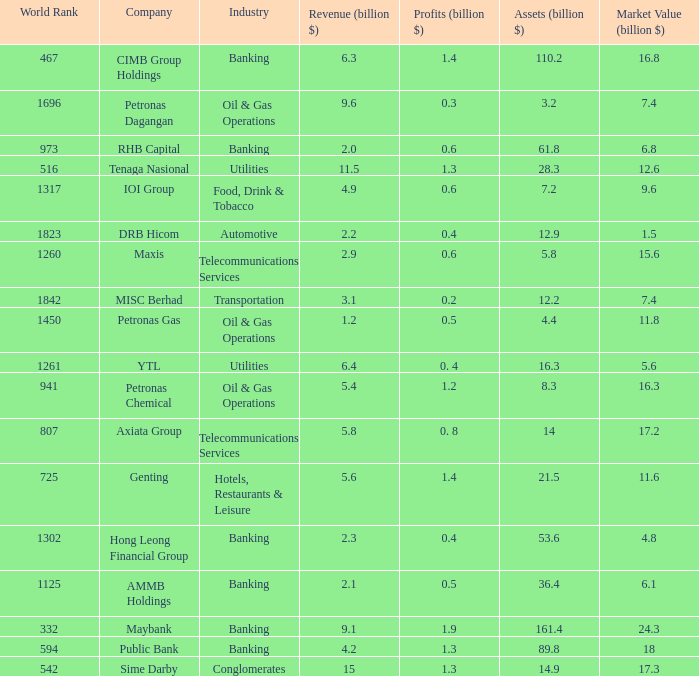Name the profits for market value of 11.8 0.5. 